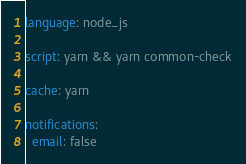<code> <loc_0><loc_0><loc_500><loc_500><_YAML_>language: node_js

script: yarn && yarn common-check

cache: yarn

notifications:
  email: false
</code> 